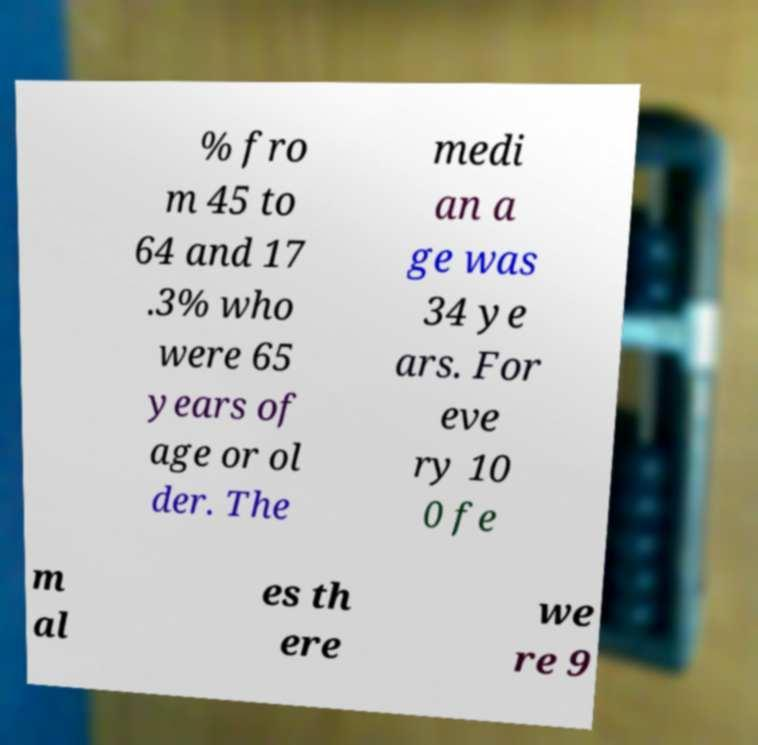For documentation purposes, I need the text within this image transcribed. Could you provide that? % fro m 45 to 64 and 17 .3% who were 65 years of age or ol der. The medi an a ge was 34 ye ars. For eve ry 10 0 fe m al es th ere we re 9 